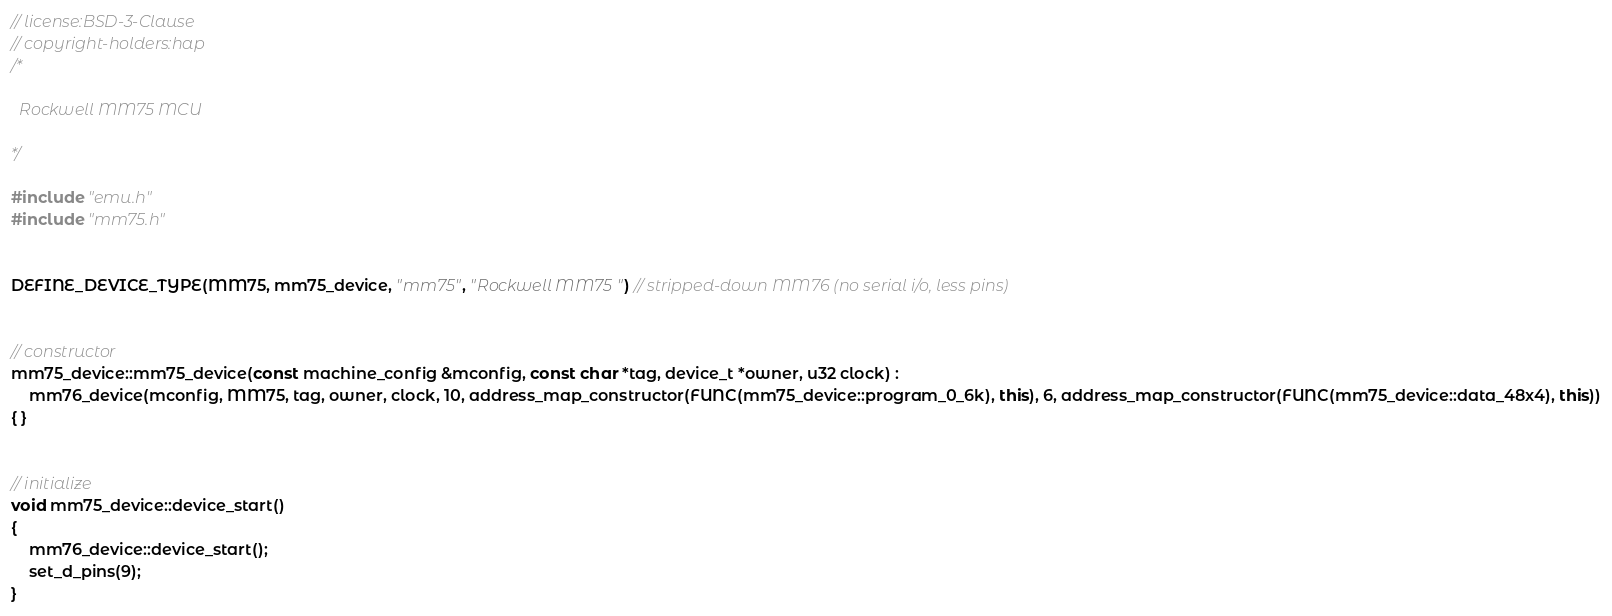Convert code to text. <code><loc_0><loc_0><loc_500><loc_500><_C++_>// license:BSD-3-Clause
// copyright-holders:hap
/*

  Rockwell MM75 MCU

*/

#include "emu.h"
#include "mm75.h"


DEFINE_DEVICE_TYPE(MM75, mm75_device, "mm75", "Rockwell MM75") // stripped-down MM76 (no serial i/o, less pins)


// constructor
mm75_device::mm75_device(const machine_config &mconfig, const char *tag, device_t *owner, u32 clock) :
	mm76_device(mconfig, MM75, tag, owner, clock, 10, address_map_constructor(FUNC(mm75_device::program_0_6k), this), 6, address_map_constructor(FUNC(mm75_device::data_48x4), this))
{ }


// initialize
void mm75_device::device_start()
{
	mm76_device::device_start();
	set_d_pins(9);
}
</code> 